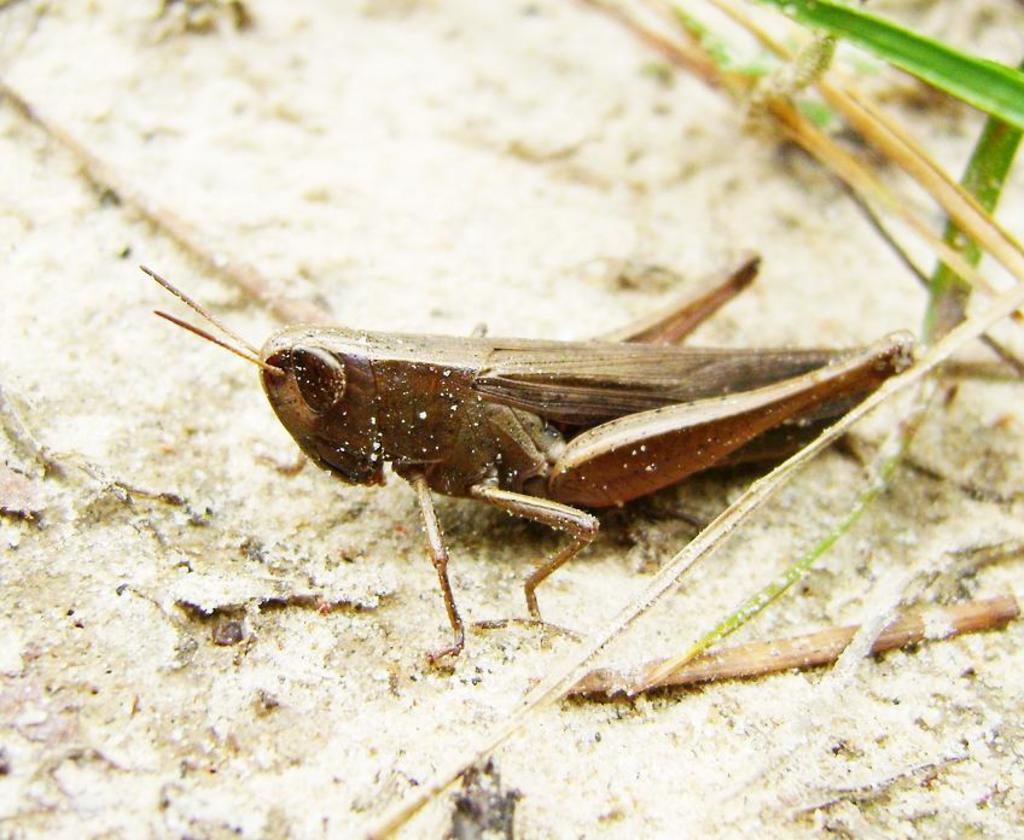Describe this image in one or two sentences. In the picture we can see an insect which is brown in color with long legs and antenna and beside the insect we can see some grass plants. 